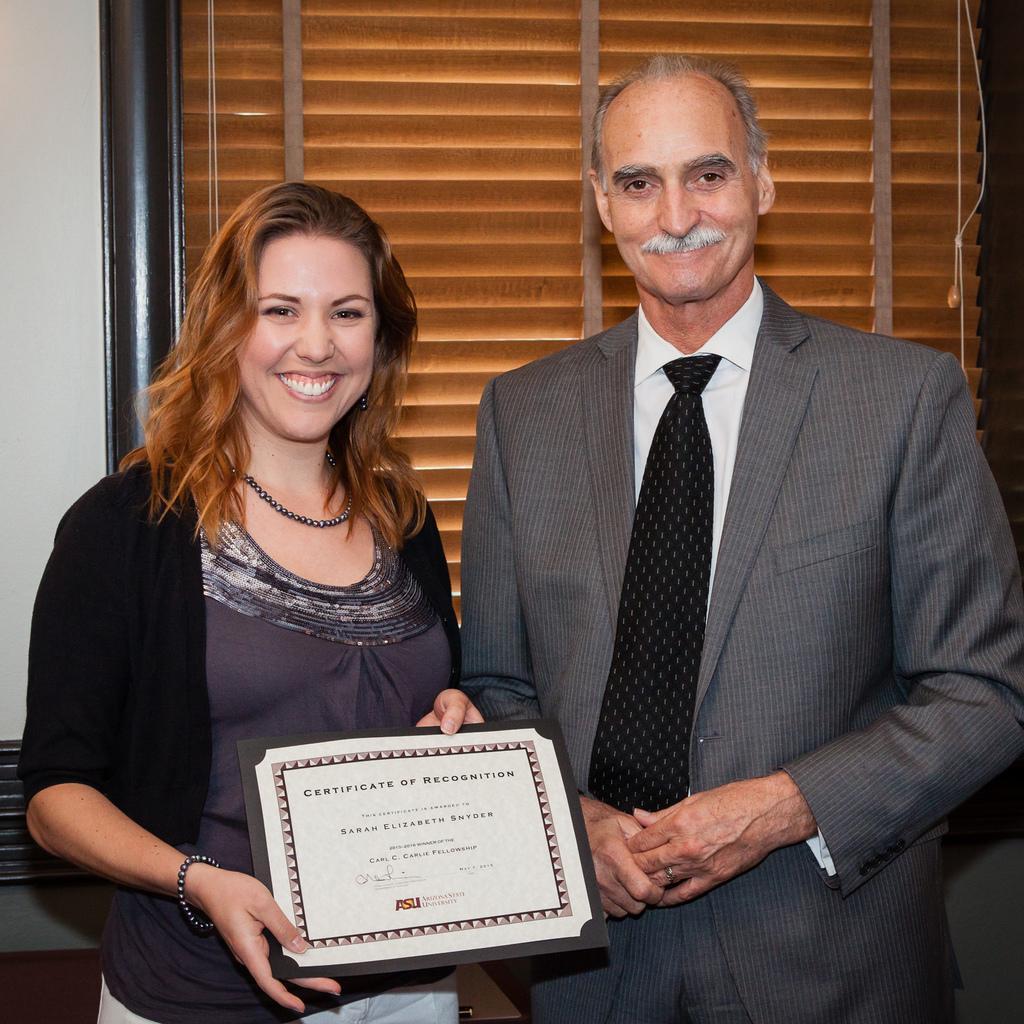Can you describe this image briefly? In this image we can see two persons standing and smiling, among them, one person is holding an object and in the background we can see the wall and a shutter. 